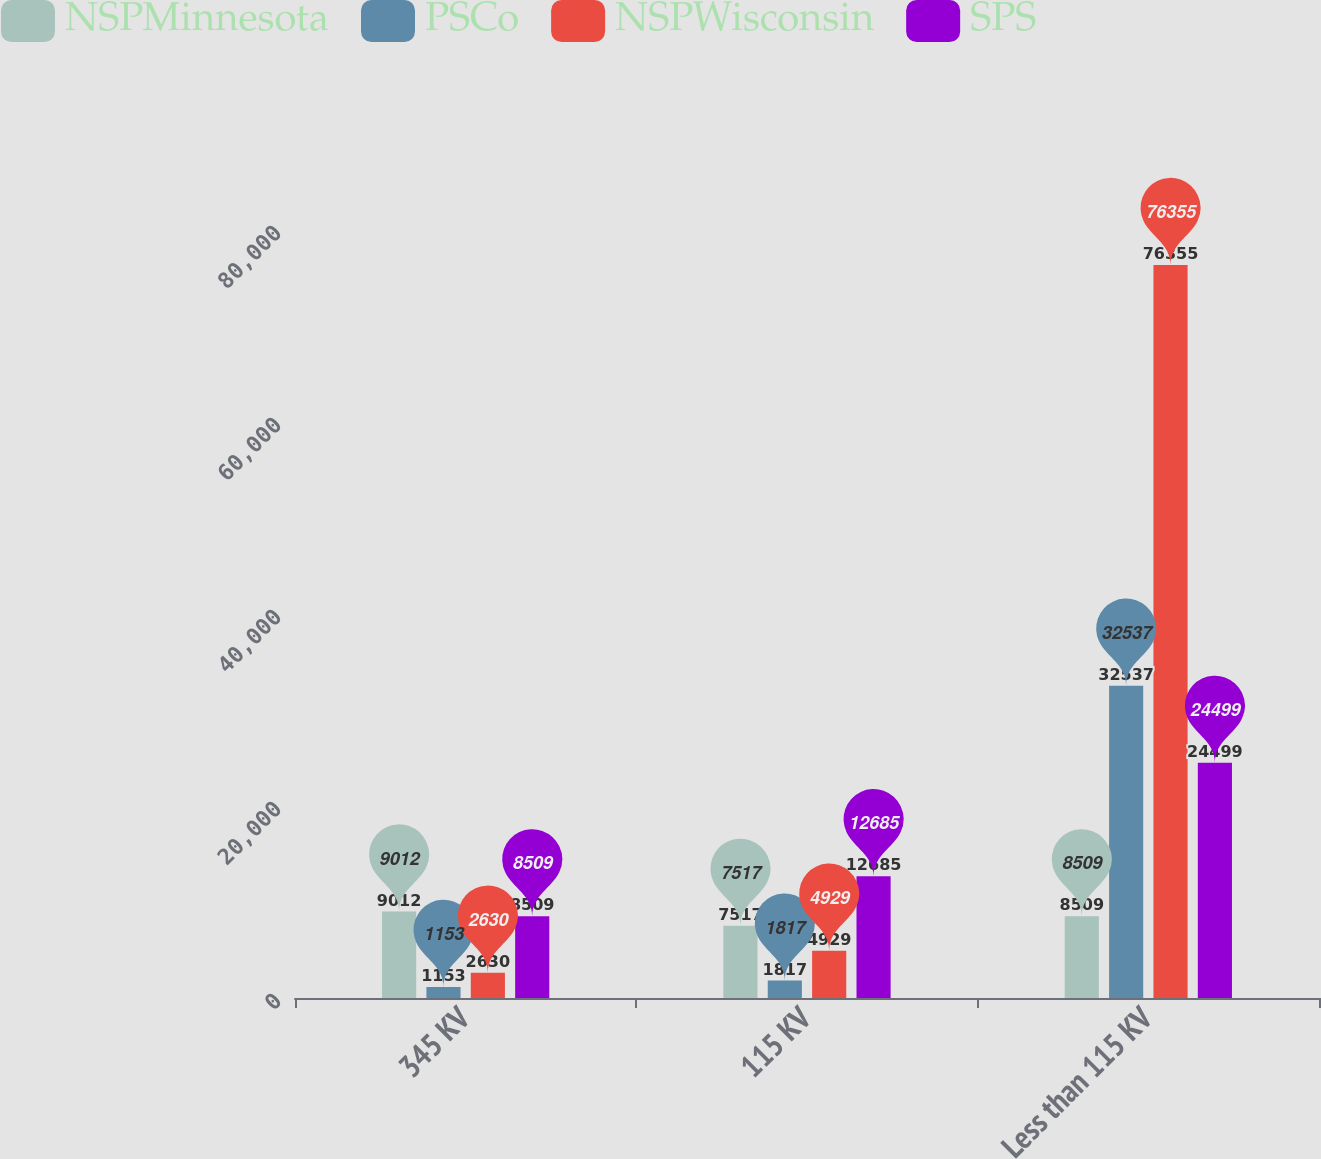Convert chart to OTSL. <chart><loc_0><loc_0><loc_500><loc_500><stacked_bar_chart><ecel><fcel>345 KV<fcel>115 KV<fcel>Less than 115 KV<nl><fcel>NSPMinnesota<fcel>9012<fcel>7517<fcel>8509<nl><fcel>PSCo<fcel>1153<fcel>1817<fcel>32537<nl><fcel>NSPWisconsin<fcel>2630<fcel>4929<fcel>76355<nl><fcel>SPS<fcel>8509<fcel>12685<fcel>24499<nl></chart> 